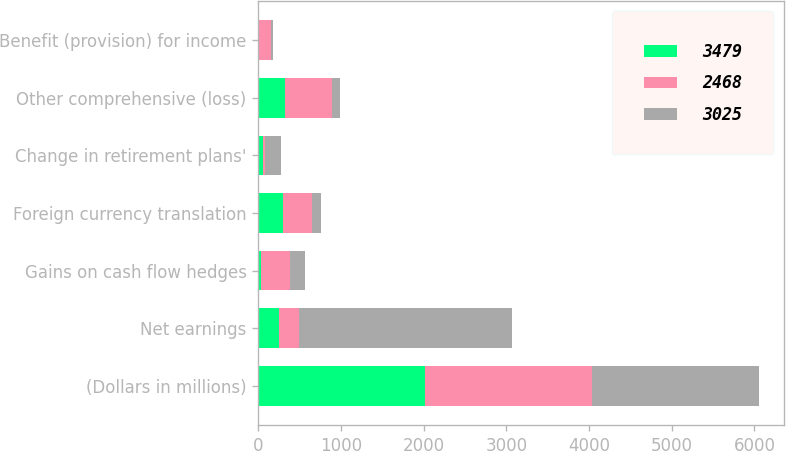Convert chart to OTSL. <chart><loc_0><loc_0><loc_500><loc_500><stacked_bar_chart><ecel><fcel>(Dollars in millions)<fcel>Net earnings<fcel>Gains on cash flow hedges<fcel>Foreign currency translation<fcel>Change in retirement plans'<fcel>Other comprehensive (loss)<fcel>Benefit (provision) for income<nl><fcel>3479<fcel>2018<fcel>246<fcel>36<fcel>300<fcel>61<fcel>320<fcel>5<nl><fcel>2468<fcel>2017<fcel>246<fcel>341<fcel>348<fcel>20<fcel>567<fcel>151<nl><fcel>3025<fcel>2016<fcel>2572<fcel>191<fcel>112<fcel>192<fcel>104<fcel>18<nl></chart> 